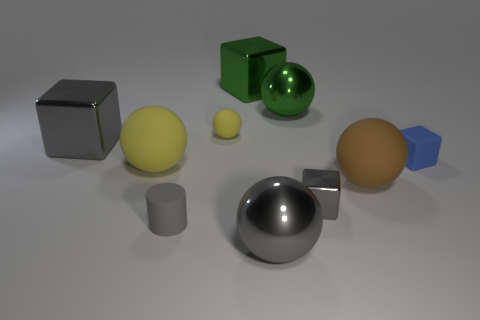How many spheres are either big green shiny things or big brown things?
Make the answer very short. 2. What is the material of the large thing that is the same color as the tiny matte sphere?
Ensure brevity in your answer.  Rubber. Does the tiny sphere have the same color as the large matte sphere left of the cylinder?
Your answer should be compact. Yes. The tiny metal cube is what color?
Ensure brevity in your answer.  Gray. What number of objects are either large red cylinders or big gray metallic blocks?
Offer a terse response. 1. There is a gray sphere that is the same size as the brown sphere; what is its material?
Provide a short and direct response. Metal. How big is the block in front of the rubber block?
Provide a succinct answer. Small. What is the big gray block made of?
Your answer should be compact. Metal. How many objects are either blocks behind the large yellow matte ball or balls on the left side of the large gray sphere?
Your answer should be compact. 5. How many other things are there of the same color as the small metallic object?
Keep it short and to the point. 3. 